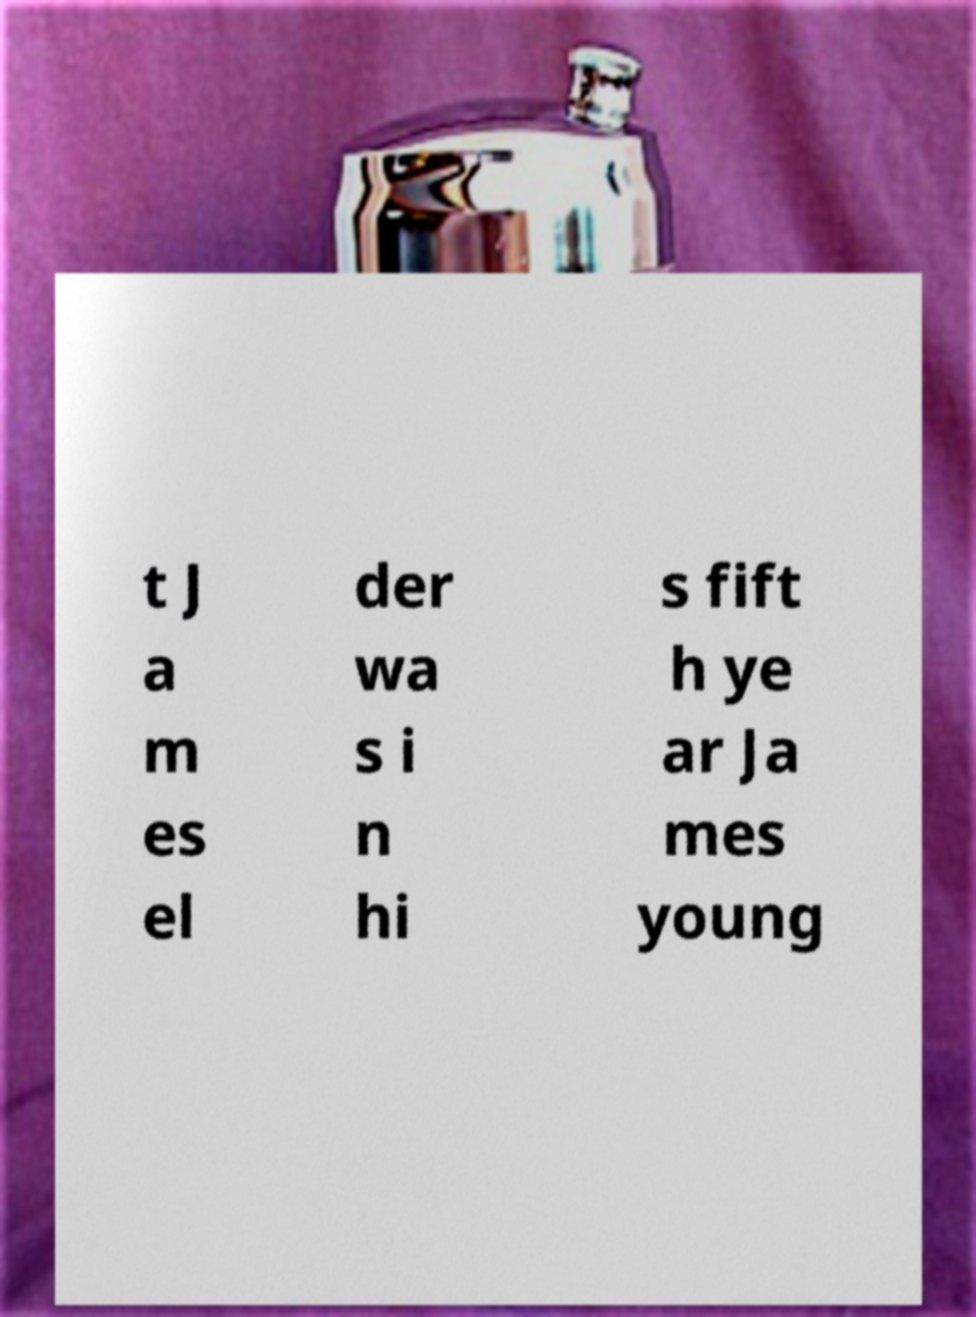I need the written content from this picture converted into text. Can you do that? t J a m es el der wa s i n hi s fift h ye ar Ja mes young 